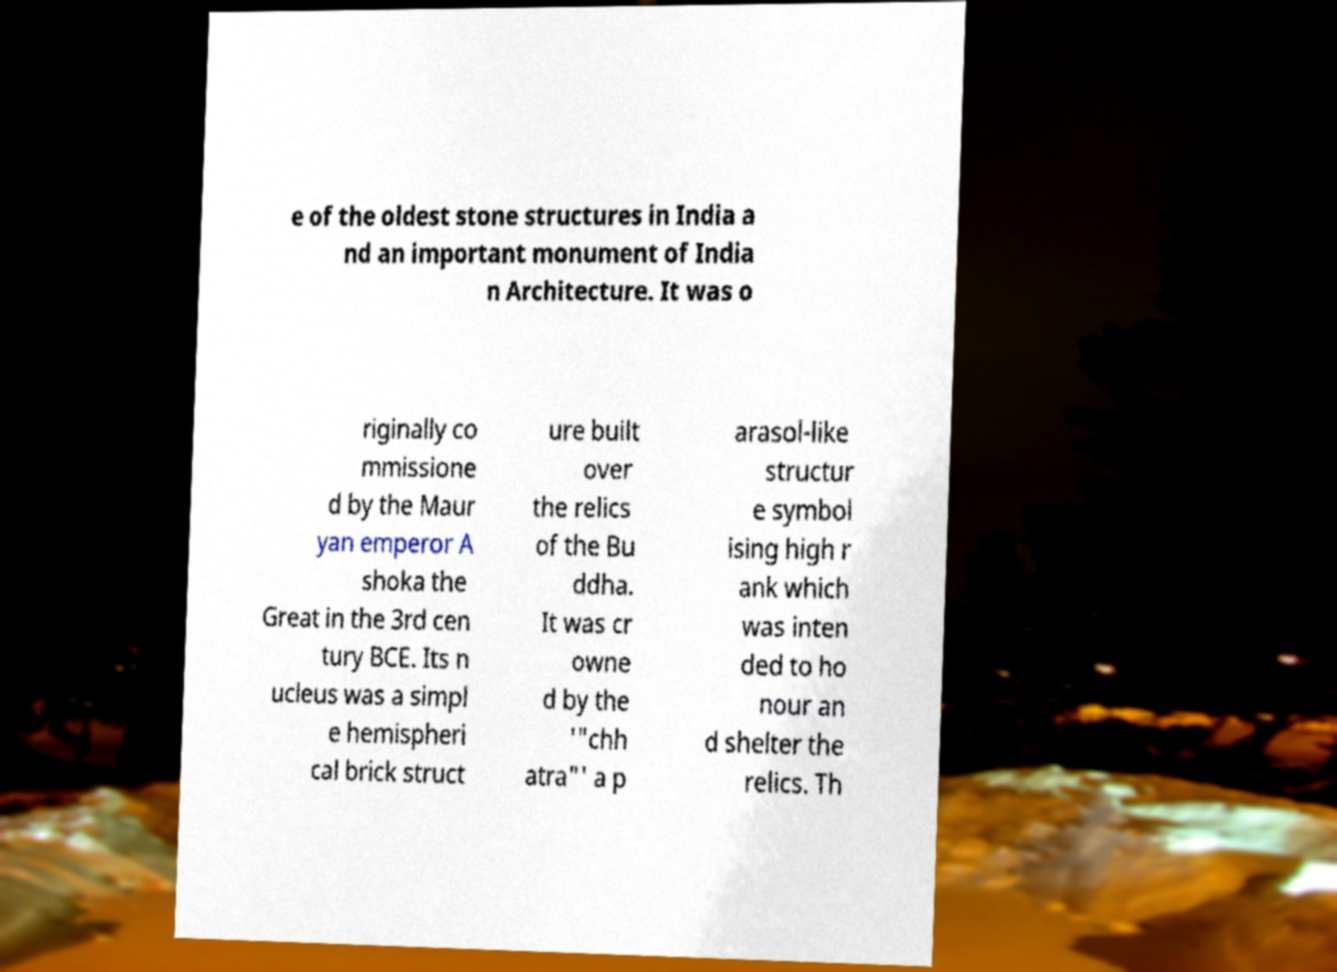Could you extract and type out the text from this image? e of the oldest stone structures in India a nd an important monument of India n Architecture. It was o riginally co mmissione d by the Maur yan emperor A shoka the Great in the 3rd cen tury BCE. Its n ucleus was a simpl e hemispheri cal brick struct ure built over the relics of the Bu ddha. It was cr owne d by the '"chh atra"' a p arasol-like structur e symbol ising high r ank which was inten ded to ho nour an d shelter the relics. Th 